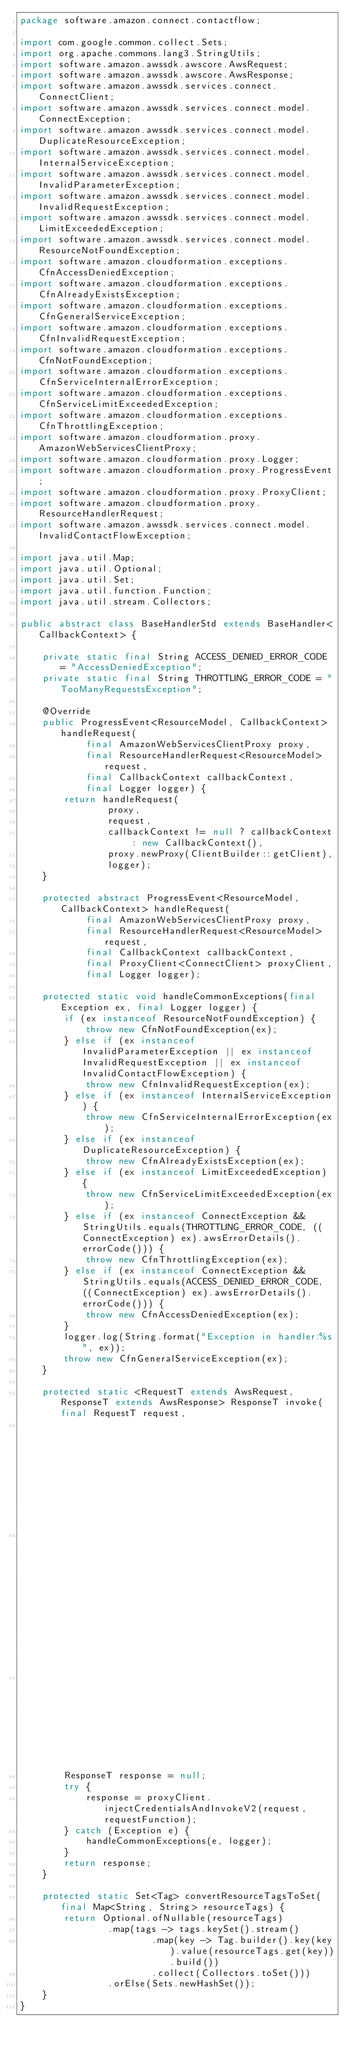<code> <loc_0><loc_0><loc_500><loc_500><_Java_>package software.amazon.connect.contactflow;

import com.google.common.collect.Sets;
import org.apache.commons.lang3.StringUtils;
import software.amazon.awssdk.awscore.AwsRequest;
import software.amazon.awssdk.awscore.AwsResponse;
import software.amazon.awssdk.services.connect.ConnectClient;
import software.amazon.awssdk.services.connect.model.ConnectException;
import software.amazon.awssdk.services.connect.model.DuplicateResourceException;
import software.amazon.awssdk.services.connect.model.InternalServiceException;
import software.amazon.awssdk.services.connect.model.InvalidParameterException;
import software.amazon.awssdk.services.connect.model.InvalidRequestException;
import software.amazon.awssdk.services.connect.model.LimitExceededException;
import software.amazon.awssdk.services.connect.model.ResourceNotFoundException;
import software.amazon.cloudformation.exceptions.CfnAccessDeniedException;
import software.amazon.cloudformation.exceptions.CfnAlreadyExistsException;
import software.amazon.cloudformation.exceptions.CfnGeneralServiceException;
import software.amazon.cloudformation.exceptions.CfnInvalidRequestException;
import software.amazon.cloudformation.exceptions.CfnNotFoundException;
import software.amazon.cloudformation.exceptions.CfnServiceInternalErrorException;
import software.amazon.cloudformation.exceptions.CfnServiceLimitExceededException;
import software.amazon.cloudformation.exceptions.CfnThrottlingException;
import software.amazon.cloudformation.proxy.AmazonWebServicesClientProxy;
import software.amazon.cloudformation.proxy.Logger;
import software.amazon.cloudformation.proxy.ProgressEvent;
import software.amazon.cloudformation.proxy.ProxyClient;
import software.amazon.cloudformation.proxy.ResourceHandlerRequest;
import software.amazon.awssdk.services.connect.model.InvalidContactFlowException;

import java.util.Map;
import java.util.Optional;
import java.util.Set;
import java.util.function.Function;
import java.util.stream.Collectors;

public abstract class BaseHandlerStd extends BaseHandler<CallbackContext> {

    private static final String ACCESS_DENIED_ERROR_CODE = "AccessDeniedException";
    private static final String THROTTLING_ERROR_CODE = "TooManyRequestsException";

    @Override
    public ProgressEvent<ResourceModel, CallbackContext> handleRequest(
            final AmazonWebServicesClientProxy proxy,
            final ResourceHandlerRequest<ResourceModel> request,
            final CallbackContext callbackContext,
            final Logger logger) {
        return handleRequest(
                proxy,
                request,
                callbackContext != null ? callbackContext : new CallbackContext(),
                proxy.newProxy(ClientBuilder::getClient),
                logger);
    }

    protected abstract ProgressEvent<ResourceModel, CallbackContext> handleRequest(
            final AmazonWebServicesClientProxy proxy,
            final ResourceHandlerRequest<ResourceModel> request,
            final CallbackContext callbackContext,
            final ProxyClient<ConnectClient> proxyClient,
            final Logger logger);

    protected static void handleCommonExceptions(final Exception ex, final Logger logger) {
        if (ex instanceof ResourceNotFoundException) {
            throw new CfnNotFoundException(ex);
        } else if (ex instanceof InvalidParameterException || ex instanceof InvalidRequestException || ex instanceof  InvalidContactFlowException) {
            throw new CfnInvalidRequestException(ex);
        } else if (ex instanceof InternalServiceException) {
            throw new CfnServiceInternalErrorException(ex);
        } else if (ex instanceof DuplicateResourceException) {
            throw new CfnAlreadyExistsException(ex);
        } else if (ex instanceof LimitExceededException) {
            throw new CfnServiceLimitExceededException(ex);
        } else if (ex instanceof ConnectException && StringUtils.equals(THROTTLING_ERROR_CODE, ((ConnectException) ex).awsErrorDetails().errorCode())) {
            throw new CfnThrottlingException(ex);
        } else if (ex instanceof ConnectException && StringUtils.equals(ACCESS_DENIED_ERROR_CODE, ((ConnectException) ex).awsErrorDetails().errorCode())) {
            throw new CfnAccessDeniedException(ex);
        }
        logger.log(String.format("Exception in handler:%s", ex));
        throw new CfnGeneralServiceException(ex);
    }

    protected static <RequestT extends AwsRequest, ResponseT extends AwsResponse> ResponseT invoke(final RequestT request,
                                                                                                   final ProxyClient<ConnectClient> proxyClient,
                                                                                                   final Function<RequestT, ResponseT> requestFunction,
                                                                                                   final Logger logger) {
        ResponseT response = null;
        try {
            response = proxyClient.injectCredentialsAndInvokeV2(request, requestFunction);
        } catch (Exception e) {
            handleCommonExceptions(e, logger);
        }
        return response;
    }

    protected static Set<Tag> convertResourceTagsToSet(final Map<String, String> resourceTags) {
        return Optional.ofNullable(resourceTags)
                .map(tags -> tags.keySet().stream()
                        .map(key -> Tag.builder().key(key).value(resourceTags.get(key)).build())
                        .collect(Collectors.toSet()))
                .orElse(Sets.newHashSet());
    }
}
</code> 